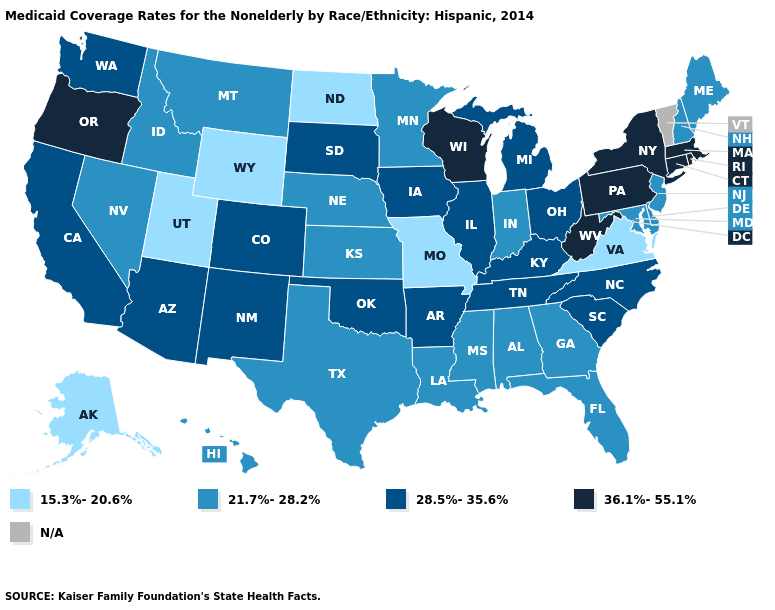Name the states that have a value in the range 36.1%-55.1%?
Answer briefly. Connecticut, Massachusetts, New York, Oregon, Pennsylvania, Rhode Island, West Virginia, Wisconsin. What is the value of Indiana?
Short answer required. 21.7%-28.2%. Name the states that have a value in the range N/A?
Give a very brief answer. Vermont. Which states have the lowest value in the USA?
Keep it brief. Alaska, Missouri, North Dakota, Utah, Virginia, Wyoming. What is the value of Wyoming?
Quick response, please. 15.3%-20.6%. What is the highest value in states that border Massachusetts?
Quick response, please. 36.1%-55.1%. What is the value of Rhode Island?
Answer briefly. 36.1%-55.1%. What is the highest value in states that border Vermont?
Write a very short answer. 36.1%-55.1%. Among the states that border Iowa , which have the lowest value?
Write a very short answer. Missouri. Does the map have missing data?
Keep it brief. Yes. Is the legend a continuous bar?
Answer briefly. No. What is the value of West Virginia?
Be succinct. 36.1%-55.1%. What is the highest value in states that border Kansas?
Keep it brief. 28.5%-35.6%. Does West Virginia have the highest value in the South?
Give a very brief answer. Yes. 